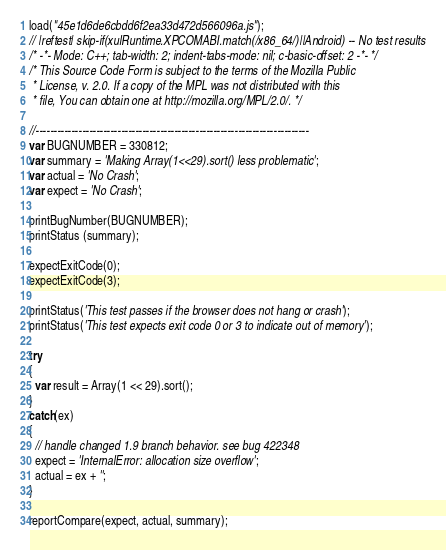Convert code to text. <code><loc_0><loc_0><loc_500><loc_500><_JavaScript_>load("45e1d6de6cbdd6f2ea33d472d566096a.js");
// |reftest| skip-if(xulRuntime.XPCOMABI.match(/x86_64/)||Android) -- No test results
/* -*- Mode: C++; tab-width: 2; indent-tabs-mode: nil; c-basic-offset: 2 -*- */
/* This Source Code Form is subject to the terms of the Mozilla Public
 * License, v. 2.0. If a copy of the MPL was not distributed with this
 * file, You can obtain one at http://mozilla.org/MPL/2.0/. */

//-----------------------------------------------------------------------------
var BUGNUMBER = 330812;
var summary = 'Making Array(1<<29).sort() less problematic';
var actual = 'No Crash';
var expect = 'No Crash';

printBugNumber(BUGNUMBER);
printStatus (summary);

expectExitCode(0);
expectExitCode(3);

printStatus('This test passes if the browser does not hang or crash');
printStatus('This test expects exit code 0 or 3 to indicate out of memory');

try
{
  var result = Array(1 << 29).sort();
}
catch(ex)
{
  // handle changed 1.9 branch behavior. see bug 422348
  expect = 'InternalError: allocation size overflow';
  actual = ex + '';
}

reportCompare(expect, actual, summary);
</code> 